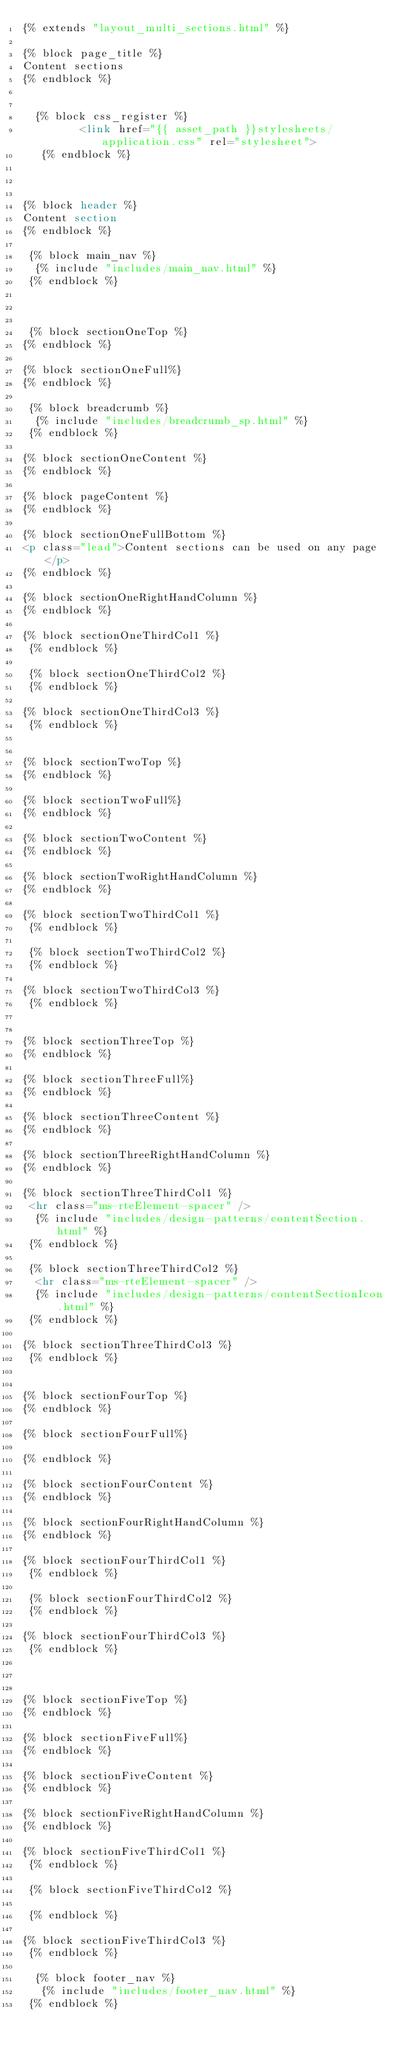Convert code to text. <code><loc_0><loc_0><loc_500><loc_500><_HTML_>{% extends "layout_multi_sections.html" %}

{% block page_title %}
Content sections
{% endblock %}


  {% block css_register %}
         <link href="{{ asset_path }}stylesheets/application.css" rel="stylesheet">
   {% endblock %}

 

{% block header %}
Content section
{% endblock %}

 {% block main_nav %}
  {% include "includes/main_nav.html" %}
 {% endblock %}



 {% block sectionOneTop %}
{% endblock %} 

{% block sectionOneFull%}
{% endblock %}

 {% block breadcrumb %}
  {% include "includes/breadcrumb_sp.html" %}
 {% endblock %}

{% block sectionOneContent %}
{% endblock %}

{% block pageContent %}
{% endblock %}

{% block sectionOneFullBottom %}
<p class="lead">Content sections can be used on any page</p>
{% endblock %}

{% block sectionOneRightHandColumn %}
{% endblock %}

{% block sectionOneThirdCol1 %}
 {% endblock %}

 {% block sectionOneThirdCol2 %}
 {% endblock %}

{% block sectionOneThirdCol3 %}
 {% endblock %}


{% block sectionTwoTop %}
{% endblock %} 

{% block sectionTwoFull%} 
{% endblock %}

{% block sectionTwoContent %}
{% endblock %}

{% block sectionTwoRightHandColumn %}
{% endblock %}

{% block sectionTwoThirdCol1 %}
 {% endblock %}

 {% block sectionTwoThirdCol2 %}
 {% endblock %}

{% block sectionTwoThirdCol3 %}
 {% endblock %}


{% block sectionThreeTop %}
{% endblock %} 

{% block sectionThreeFull%}
{% endblock %}

{% block sectionThreeContent %}
{% endblock %}

{% block sectionThreeRightHandColumn %}
{% endblock %}

{% block sectionThreeThirdCol1 %}
 <hr class="ms-rteElement-spacer" />
  {% include "includes/design-patterns/contentSection.html" %}
 {% endblock %}

 {% block sectionThreeThirdCol2 %}
  <hr class="ms-rteElement-spacer" />
  {% include "includes/design-patterns/contentSectionIcon.html" %}
 {% endblock %}

{% block sectionThreeThirdCol3 %}
 {% endblock %}


{% block sectionFourTop %}
{% endblock %} 

{% block sectionFourFull%}

{% endblock %}

{% block sectionFourContent %}
{% endblock %}

{% block sectionFourRightHandColumn %}
{% endblock %}

{% block sectionFourThirdCol1 %}
 {% endblock %}

 {% block sectionFourThirdCol2 %}
 {% endblock %}

{% block sectionFourThirdCol3 %}
 {% endblock %}



{% block sectionFiveTop %}
{% endblock %} 

{% block sectionFiveFull%}
{% endblock %}

{% block sectionFiveContent %}
{% endblock %}

{% block sectionFiveRightHandColumn %}
{% endblock %}

{% block sectionFiveThirdCol1 %}
 {% endblock %}

 {% block sectionFiveThirdCol2 %}

 {% endblock %}

{% block sectionFiveThirdCol3 %}
 {% endblock %}

  {% block footer_nav %}
   {% include "includes/footer_nav.html" %}
 {% endblock %}</code> 